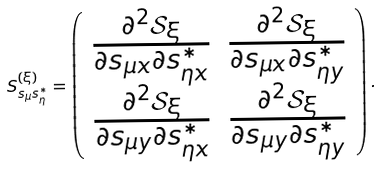Convert formula to latex. <formula><loc_0><loc_0><loc_500><loc_500>S ^ { ( \xi ) } _ { s _ { \mu } s ^ { * } _ { \eta } } = \left ( \begin{array} { c c } \frac { \partial ^ { 2 } \mathcal { S } _ { \xi } } { \partial s _ { \mu x } \partial s ^ { * } _ { \eta x } } & \frac { \partial ^ { 2 } \mathcal { S } _ { \xi } } { \partial s _ { \mu x } \partial s ^ { * } _ { \eta y } } \\ \frac { \partial ^ { 2 } \mathcal { S } _ { \xi } } { \partial s _ { \mu y } \partial s ^ { * } _ { \eta x } } & \frac { \partial ^ { 2 } \mathcal { S } _ { \xi } } { \partial s _ { \mu y } \partial s ^ { * } _ { \eta y } } \end{array} \right ) .</formula> 